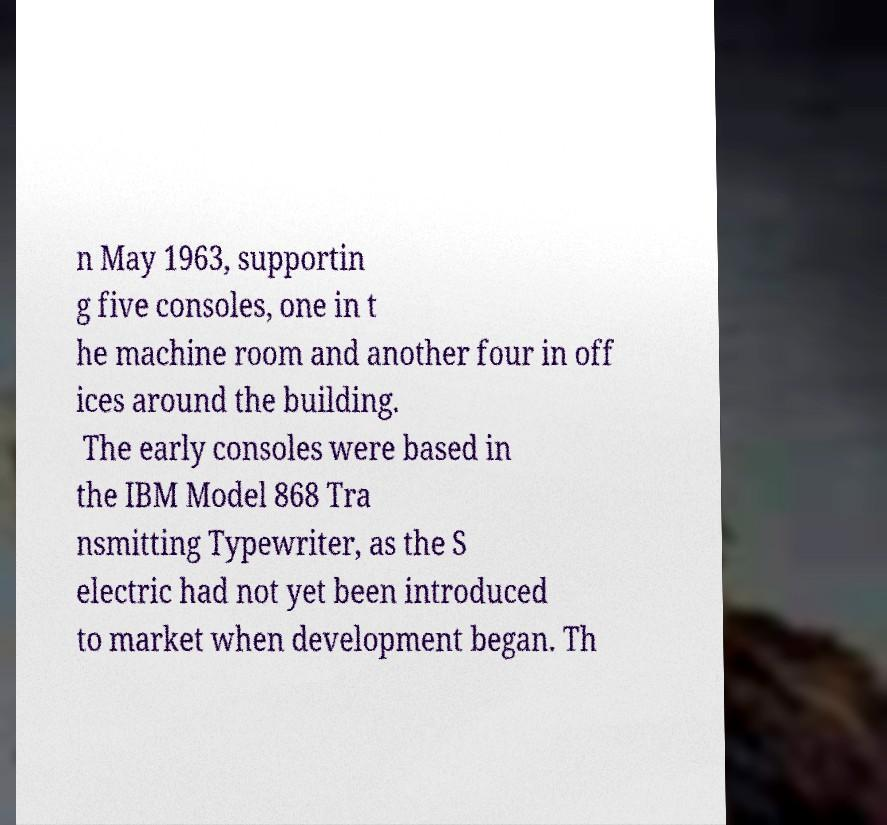Could you assist in decoding the text presented in this image and type it out clearly? n May 1963, supportin g five consoles, one in t he machine room and another four in off ices around the building. The early consoles were based in the IBM Model 868 Tra nsmitting Typewriter, as the S electric had not yet been introduced to market when development began. Th 